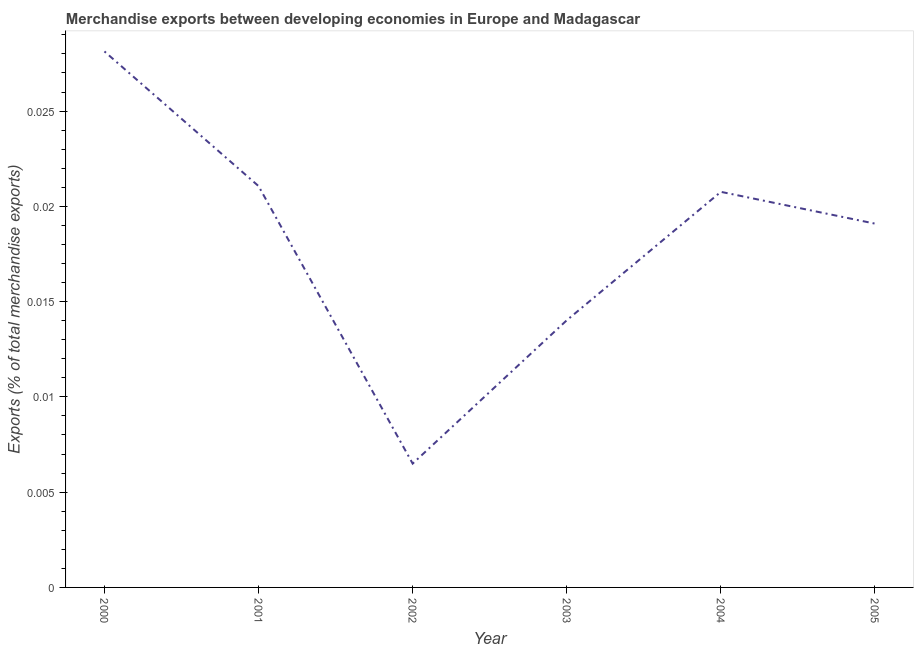What is the merchandise exports in 2004?
Provide a succinct answer. 0.02. Across all years, what is the maximum merchandise exports?
Give a very brief answer. 0.03. Across all years, what is the minimum merchandise exports?
Make the answer very short. 0.01. In which year was the merchandise exports maximum?
Provide a succinct answer. 2000. In which year was the merchandise exports minimum?
Provide a short and direct response. 2002. What is the sum of the merchandise exports?
Keep it short and to the point. 0.11. What is the difference between the merchandise exports in 2003 and 2004?
Make the answer very short. -0.01. What is the average merchandise exports per year?
Make the answer very short. 0.02. What is the median merchandise exports?
Provide a succinct answer. 0.02. In how many years, is the merchandise exports greater than 0.023 %?
Make the answer very short. 1. Do a majority of the years between 2005 and 2002 (inclusive) have merchandise exports greater than 0.017 %?
Offer a terse response. Yes. What is the ratio of the merchandise exports in 2000 to that in 2003?
Keep it short and to the point. 2.01. Is the merchandise exports in 2002 less than that in 2004?
Ensure brevity in your answer.  Yes. Is the difference between the merchandise exports in 2000 and 2003 greater than the difference between any two years?
Give a very brief answer. No. What is the difference between the highest and the second highest merchandise exports?
Provide a succinct answer. 0.01. What is the difference between the highest and the lowest merchandise exports?
Your answer should be very brief. 0.02. In how many years, is the merchandise exports greater than the average merchandise exports taken over all years?
Keep it short and to the point. 4. Does the merchandise exports monotonically increase over the years?
Offer a very short reply. No. How many lines are there?
Your response must be concise. 1. How many years are there in the graph?
Make the answer very short. 6. What is the difference between two consecutive major ticks on the Y-axis?
Make the answer very short. 0.01. Does the graph contain grids?
Give a very brief answer. No. What is the title of the graph?
Keep it short and to the point. Merchandise exports between developing economies in Europe and Madagascar. What is the label or title of the Y-axis?
Keep it short and to the point. Exports (% of total merchandise exports). What is the Exports (% of total merchandise exports) of 2000?
Your response must be concise. 0.03. What is the Exports (% of total merchandise exports) in 2001?
Your answer should be compact. 0.02. What is the Exports (% of total merchandise exports) in 2002?
Give a very brief answer. 0.01. What is the Exports (% of total merchandise exports) of 2003?
Keep it short and to the point. 0.01. What is the Exports (% of total merchandise exports) of 2004?
Offer a very short reply. 0.02. What is the Exports (% of total merchandise exports) of 2005?
Your response must be concise. 0.02. What is the difference between the Exports (% of total merchandise exports) in 2000 and 2001?
Give a very brief answer. 0.01. What is the difference between the Exports (% of total merchandise exports) in 2000 and 2002?
Provide a succinct answer. 0.02. What is the difference between the Exports (% of total merchandise exports) in 2000 and 2003?
Provide a short and direct response. 0.01. What is the difference between the Exports (% of total merchandise exports) in 2000 and 2004?
Your answer should be very brief. 0.01. What is the difference between the Exports (% of total merchandise exports) in 2000 and 2005?
Ensure brevity in your answer.  0.01. What is the difference between the Exports (% of total merchandise exports) in 2001 and 2002?
Provide a short and direct response. 0.01. What is the difference between the Exports (% of total merchandise exports) in 2001 and 2003?
Your answer should be compact. 0.01. What is the difference between the Exports (% of total merchandise exports) in 2001 and 2005?
Provide a succinct answer. 0. What is the difference between the Exports (% of total merchandise exports) in 2002 and 2003?
Your answer should be very brief. -0.01. What is the difference between the Exports (% of total merchandise exports) in 2002 and 2004?
Your answer should be very brief. -0.01. What is the difference between the Exports (% of total merchandise exports) in 2002 and 2005?
Offer a terse response. -0.01. What is the difference between the Exports (% of total merchandise exports) in 2003 and 2004?
Your answer should be very brief. -0.01. What is the difference between the Exports (% of total merchandise exports) in 2003 and 2005?
Offer a very short reply. -0.01. What is the difference between the Exports (% of total merchandise exports) in 2004 and 2005?
Your answer should be very brief. 0. What is the ratio of the Exports (% of total merchandise exports) in 2000 to that in 2001?
Provide a short and direct response. 1.34. What is the ratio of the Exports (% of total merchandise exports) in 2000 to that in 2002?
Offer a terse response. 4.33. What is the ratio of the Exports (% of total merchandise exports) in 2000 to that in 2003?
Give a very brief answer. 2.01. What is the ratio of the Exports (% of total merchandise exports) in 2000 to that in 2004?
Your answer should be very brief. 1.35. What is the ratio of the Exports (% of total merchandise exports) in 2000 to that in 2005?
Make the answer very short. 1.47. What is the ratio of the Exports (% of total merchandise exports) in 2001 to that in 2002?
Your answer should be very brief. 3.24. What is the ratio of the Exports (% of total merchandise exports) in 2001 to that in 2003?
Ensure brevity in your answer.  1.5. What is the ratio of the Exports (% of total merchandise exports) in 2001 to that in 2004?
Offer a terse response. 1.01. What is the ratio of the Exports (% of total merchandise exports) in 2001 to that in 2005?
Provide a succinct answer. 1.1. What is the ratio of the Exports (% of total merchandise exports) in 2002 to that in 2003?
Your answer should be very brief. 0.46. What is the ratio of the Exports (% of total merchandise exports) in 2002 to that in 2004?
Your answer should be very brief. 0.31. What is the ratio of the Exports (% of total merchandise exports) in 2002 to that in 2005?
Provide a succinct answer. 0.34. What is the ratio of the Exports (% of total merchandise exports) in 2003 to that in 2004?
Keep it short and to the point. 0.68. What is the ratio of the Exports (% of total merchandise exports) in 2003 to that in 2005?
Offer a very short reply. 0.73. What is the ratio of the Exports (% of total merchandise exports) in 2004 to that in 2005?
Your answer should be compact. 1.09. 